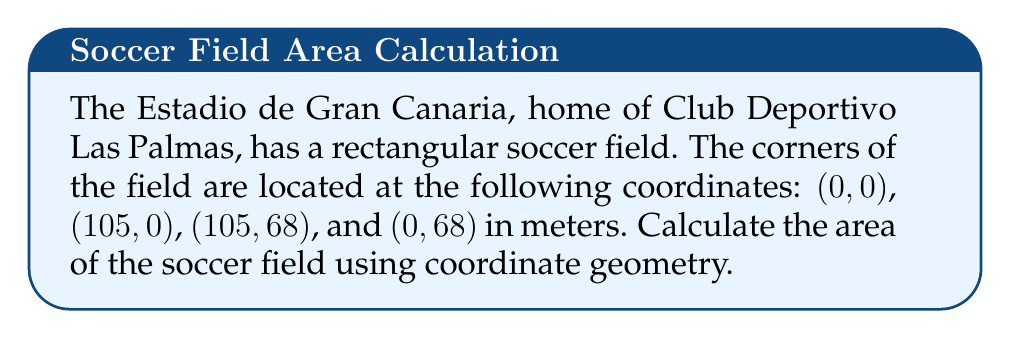What is the answer to this math problem? To calculate the area of the rectangular soccer field using coordinate geometry, we can follow these steps:

1. Identify the coordinates of the corners:
   A(0, 0), B(105, 0), C(105, 68), D(0, 68)

2. Calculate the length of the field:
   Length = $|x_B - x_A| = |105 - 0| = 105$ meters

3. Calculate the width of the field:
   Width = $|y_C - y_B| = |68 - 0| = 68$ meters

4. Apply the formula for the area of a rectangle:
   Area = Length × Width
   
   $$\text{Area} = 105 \times 68 = 7140 \text{ square meters}$$

[asy]
unitsize(1cm);
draw((0,0)--(10.5,0)--(10.5,6.8)--(0,6.8)--cycle);
label("A(0,0)", (0,0), SW);
label("B(105,0)", (10.5,0), SE);
label("C(105,68)", (10.5,6.8), NE);
label("D(0,68)", (0,6.8), NW);
label("105 m", (5.25,0), S);
label("68 m", (10.5,3.4), E);
[/asy]
Answer: 7140 m² 